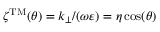<formula> <loc_0><loc_0><loc_500><loc_500>\zeta ^ { T M } ( \theta ) = k _ { \perp } / ( \omega \varepsilon ) = \eta \cos ( \theta )</formula> 